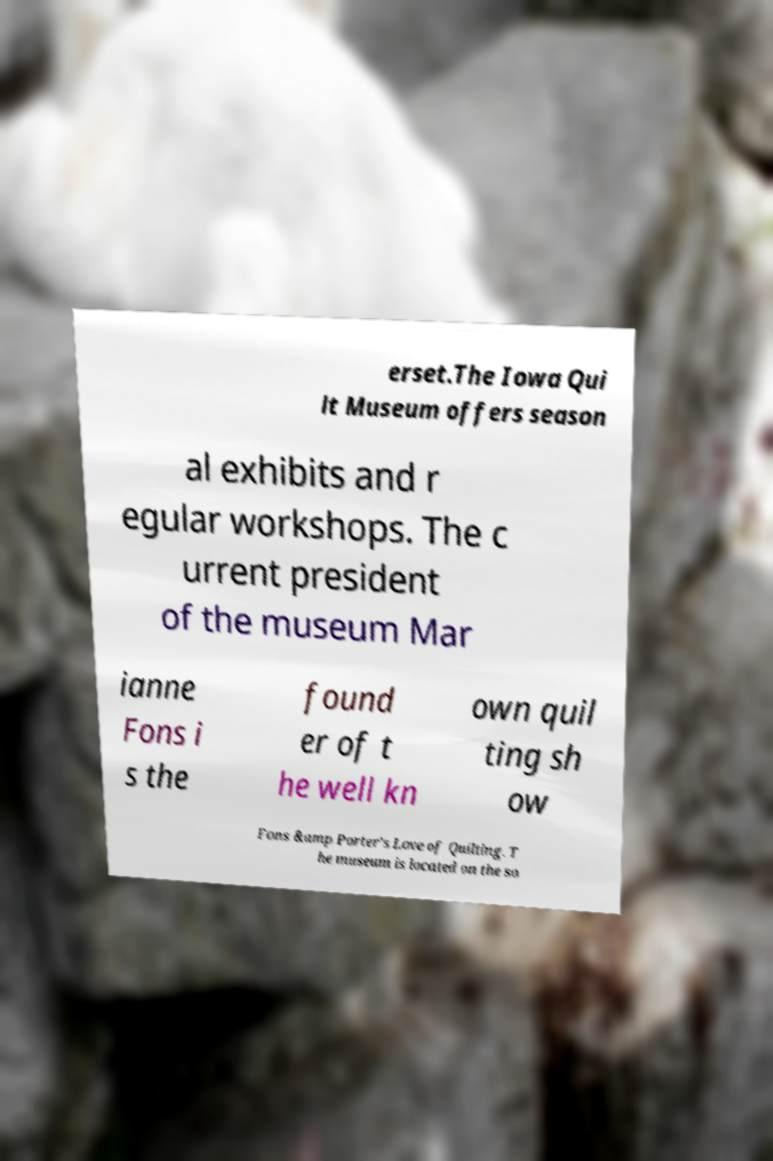I need the written content from this picture converted into text. Can you do that? erset.The Iowa Qui lt Museum offers season al exhibits and r egular workshops. The c urrent president of the museum Mar ianne Fons i s the found er of t he well kn own quil ting sh ow Fons &amp Porter's Love of Quilting. T he museum is located on the so 